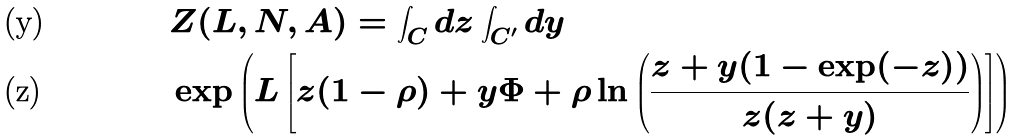Convert formula to latex. <formula><loc_0><loc_0><loc_500><loc_500>& Z ( L , N , A ) = \int _ { C } d z \int _ { C ^ { \prime } } d y \\ & \exp \left ( L \left [ z ( 1 - \rho ) + y \Phi + \rho \ln \left ( \frac { z + y ( 1 - \exp ( - z ) ) } { z ( z + y ) } \right ) \right ] \right )</formula> 